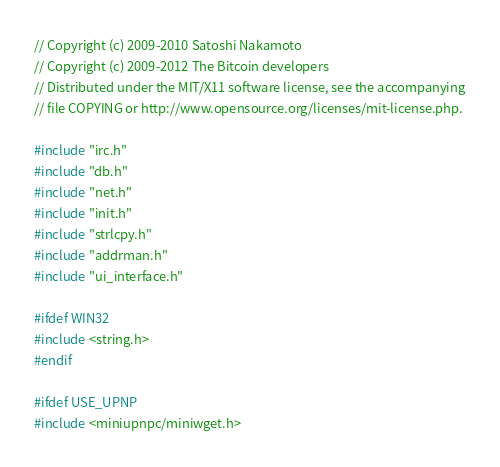<code> <loc_0><loc_0><loc_500><loc_500><_C++_>// Copyright (c) 2009-2010 Satoshi Nakamoto
// Copyright (c) 2009-2012 The Bitcoin developers
// Distributed under the MIT/X11 software license, see the accompanying
// file COPYING or http://www.opensource.org/licenses/mit-license.php.

#include "irc.h"
#include "db.h"
#include "net.h"
#include "init.h"
#include "strlcpy.h"
#include "addrman.h"
#include "ui_interface.h"

#ifdef WIN32
#include <string.h>
#endif

#ifdef USE_UPNP
#include <miniupnpc/miniwget.h></code> 